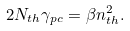Convert formula to latex. <formula><loc_0><loc_0><loc_500><loc_500>2 N _ { t h } \gamma _ { p c } = \beta n _ { t h } ^ { 2 } .</formula> 